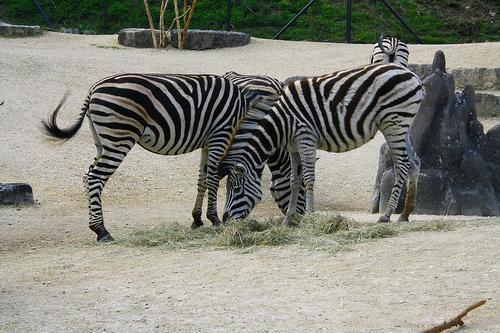How many zebras are shown?
Give a very brief answer. 3. How many zebra eyes are shown?
Give a very brief answer. 1. How many zebras are there?
Give a very brief answer. 3. 